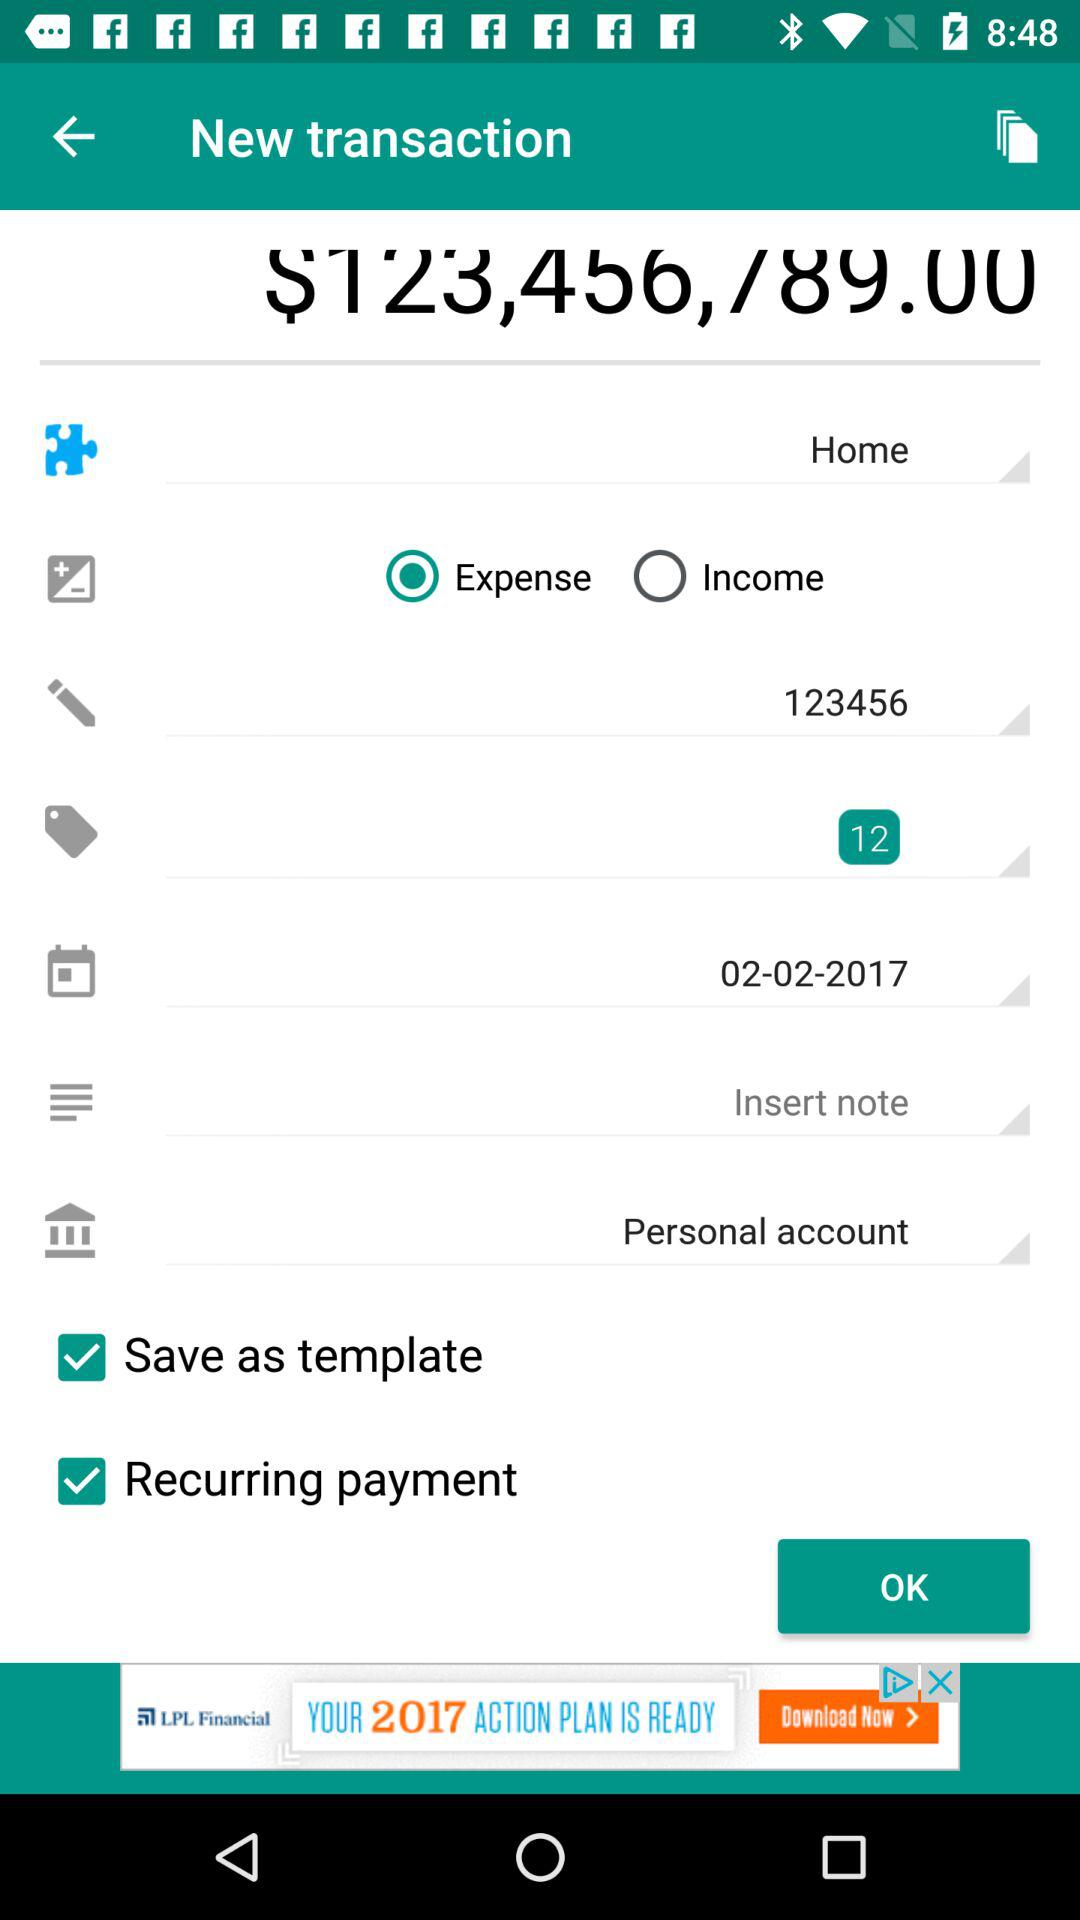What is the transaction amount?
When the provided information is insufficient, respond with <no answer>. <no answer> 